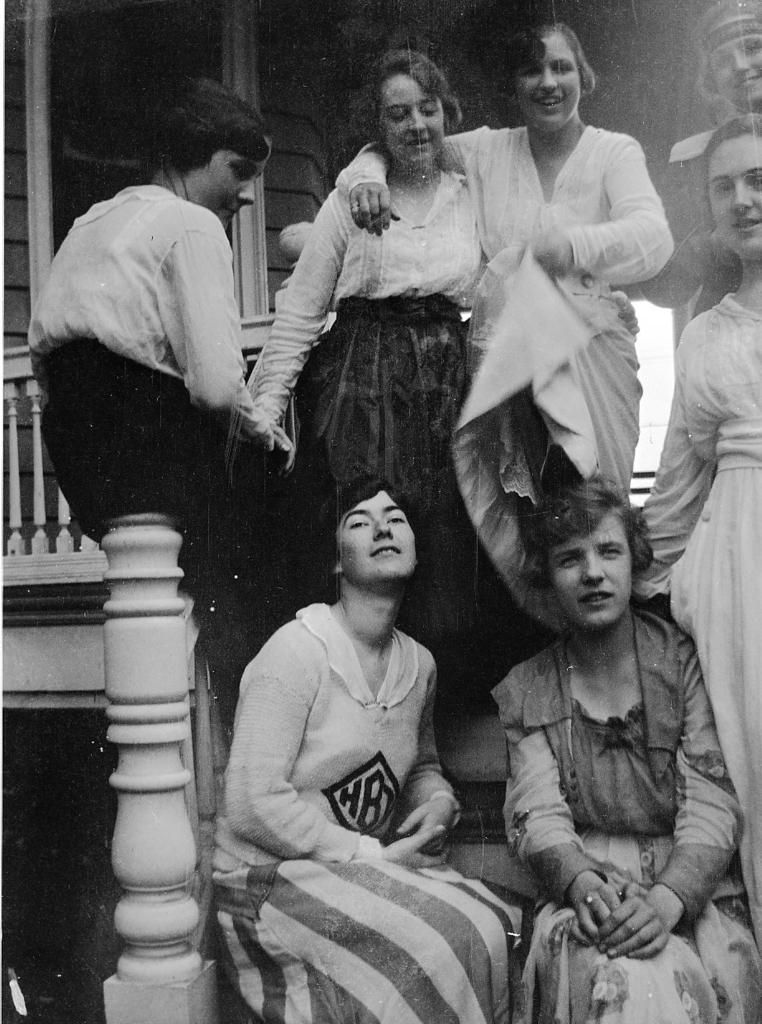What is the color scheme of the image? The image is black and white. What can be seen in terms of human presence in the image? There is a group of people standing in the image, and two persons are sitting on the stairs. What type of brick is being used to construct the stairs in the image? There is no mention of stairs being constructed with brick in the image, nor is there any visible brick. 